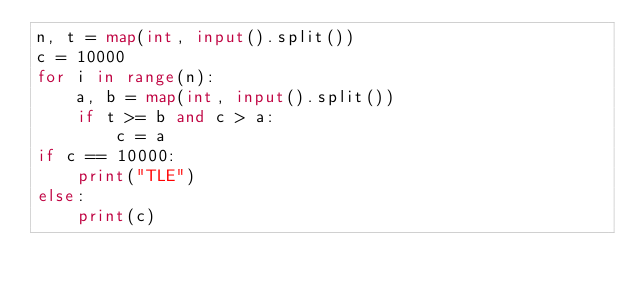<code> <loc_0><loc_0><loc_500><loc_500><_Python_>n, t = map(int, input().split())
c = 10000
for i in range(n):
    a, b = map(int, input().split())
    if t >= b and c > a:
        c = a
if c == 10000:
    print("TLE")
else:
    print(c)
</code> 